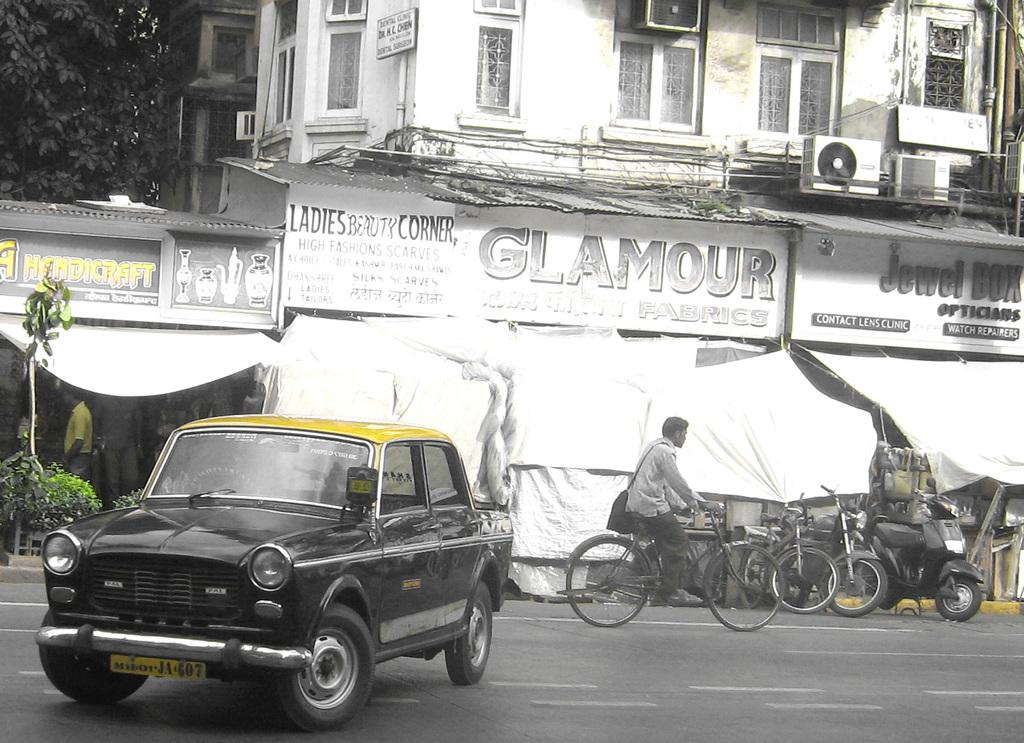What is the main subject of the image? There is a person riding a bicycle in the image. What can be seen behind the person on the bicycle? A car is parked behind the person. What type of structures are visible in the image? There are buildings in the image. What type of vegetation is present in the image? Trees are present in the image. How would you describe the weather in the image? The background of the image is sunny. What type of punishment is the person on the bicycle receiving in the image? There is no indication of punishment in the image; the person is simply riding a bicycle. What does the person on the bicycle regret in the image? There is no indication of regret in the image; the person is simply riding a bicycle. 